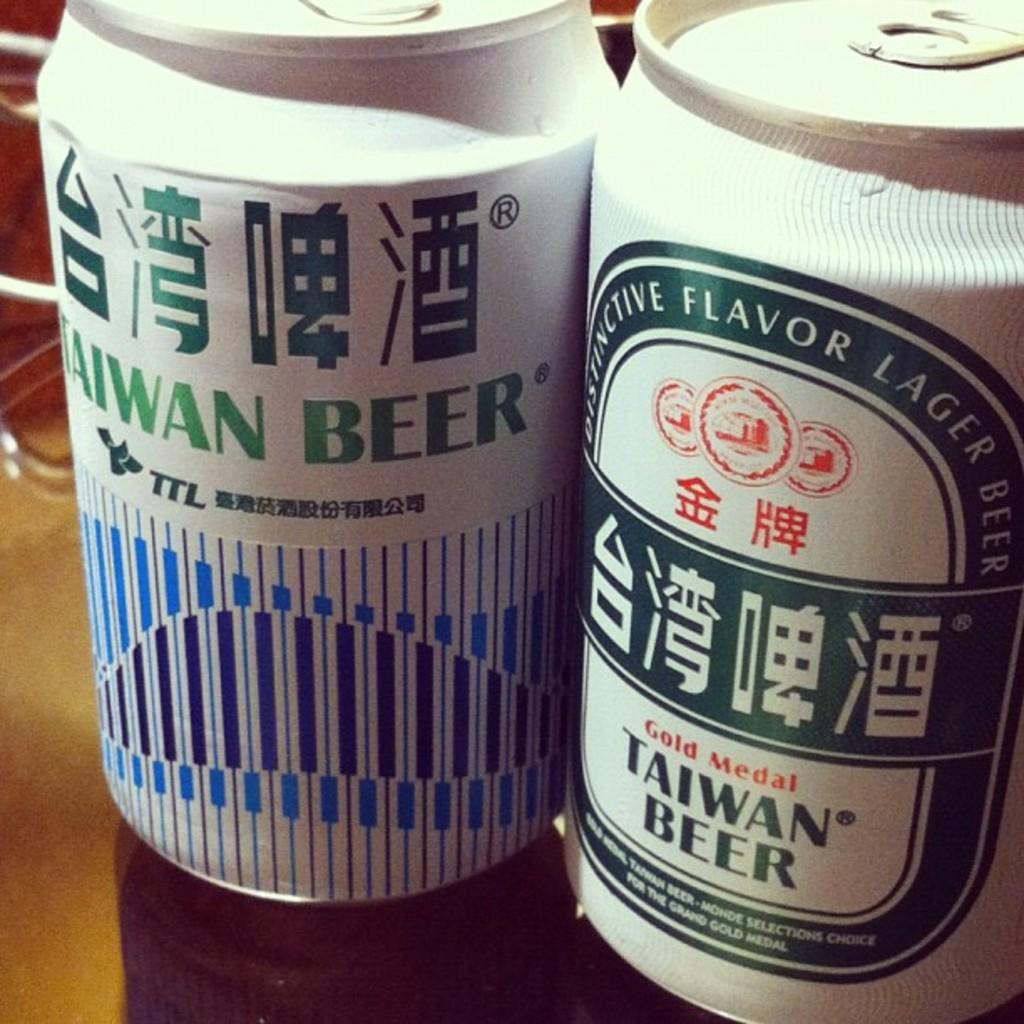Provide a one-sentence caption for the provided image. Two cans of Taiwan Beer standing next to each other. 